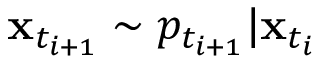Convert formula to latex. <formula><loc_0><loc_0><loc_500><loc_500>x _ { t _ { i + 1 } } \sim p _ { t _ { i + 1 } } | x _ { t _ { i } }</formula> 